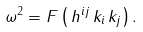Convert formula to latex. <formula><loc_0><loc_0><loc_500><loc_500>\omega ^ { 2 } = F \left ( \, h ^ { i j } \, k _ { i } \, k _ { j } \right ) .</formula> 